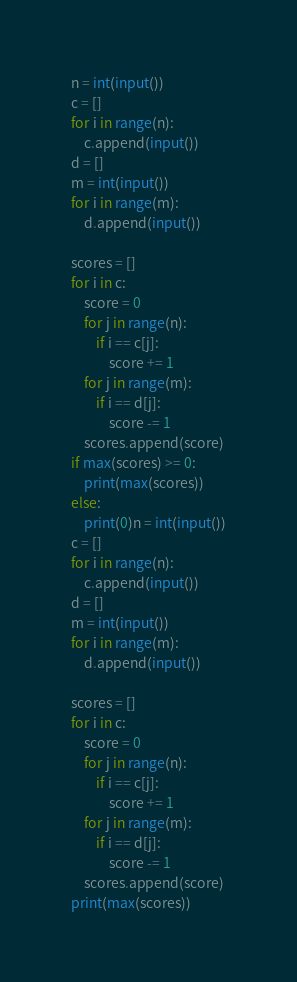<code> <loc_0><loc_0><loc_500><loc_500><_Python_>n = int(input())
c = []
for i in range(n):
    c.append(input())
d = []
m = int(input())
for i in range(m):
    d.append(input())

scores = []
for i in c:
    score = 0
    for j in range(n):
        if i == c[j]:
            score += 1
    for j in range(m):
        if i == d[j]:
            score -= 1
    scores.append(score)
if max(scores) >= 0:
    print(max(scores))
else:
    print(0)n = int(input())
c = []
for i in range(n):
    c.append(input())
d = []
m = int(input())
for i in range(m):
    d.append(input())

scores = []
for i in c:
    score = 0
    for j in range(n):
        if i == c[j]:
            score += 1
    for j in range(m):
        if i == d[j]:
            score -= 1
    scores.append(score)
print(max(scores))</code> 